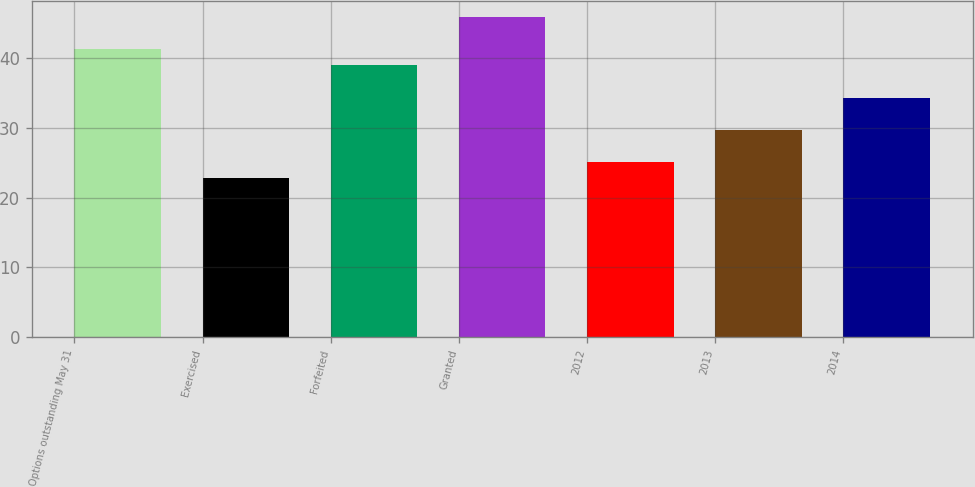<chart> <loc_0><loc_0><loc_500><loc_500><bar_chart><fcel>Options outstanding May 31<fcel>Exercised<fcel>Forfeited<fcel>Granted<fcel>2012<fcel>2013<fcel>2014<nl><fcel>41.29<fcel>22.81<fcel>38.98<fcel>45.87<fcel>25.12<fcel>29.74<fcel>34.36<nl></chart> 